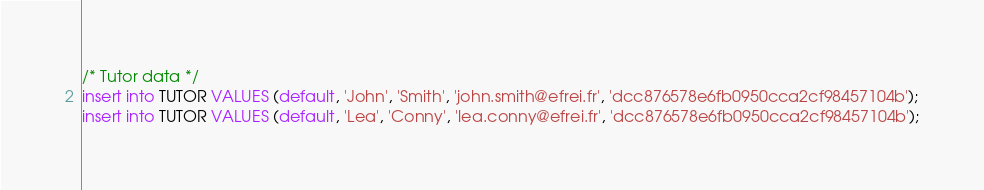Convert code to text. <code><loc_0><loc_0><loc_500><loc_500><_SQL_>/* Tutor data */
insert into TUTOR VALUES (default, 'John', 'Smith', 'john.smith@efrei.fr', 'dcc876578e6fb0950cca2cf98457104b');
insert into TUTOR VALUES (default, 'Lea', 'Conny', 'lea.conny@efrei.fr', 'dcc876578e6fb0950cca2cf98457104b');</code> 